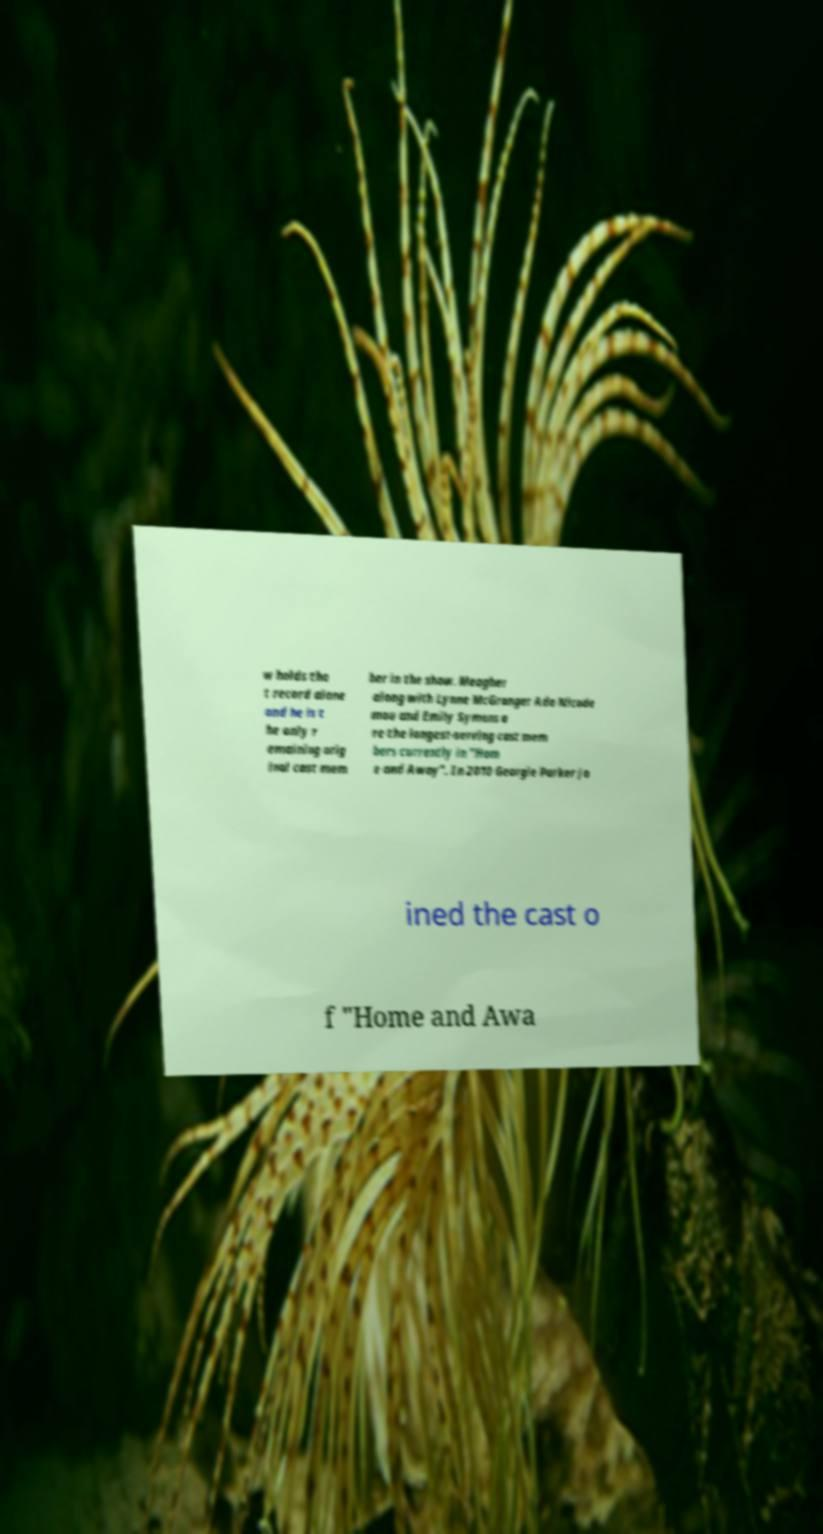There's text embedded in this image that I need extracted. Can you transcribe it verbatim? w holds tha t record alone and he is t he only r emaining orig inal cast mem ber in the show. Meagher along with Lynne McGranger Ada Nicode mou and Emily Symons a re the longest-serving cast mem bers currently in "Hom e and Away". In 2010 Georgie Parker jo ined the cast o f "Home and Awa 